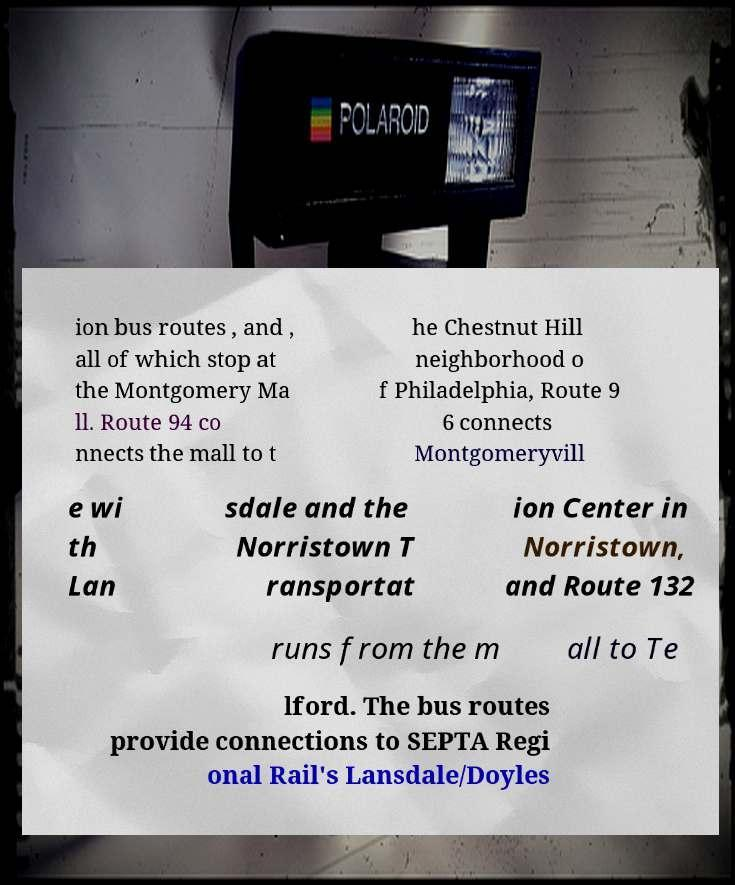Can you accurately transcribe the text from the provided image for me? ion bus routes , and , all of which stop at the Montgomery Ma ll. Route 94 co nnects the mall to t he Chestnut Hill neighborhood o f Philadelphia, Route 9 6 connects Montgomeryvill e wi th Lan sdale and the Norristown T ransportat ion Center in Norristown, and Route 132 runs from the m all to Te lford. The bus routes provide connections to SEPTA Regi onal Rail's Lansdale/Doyles 